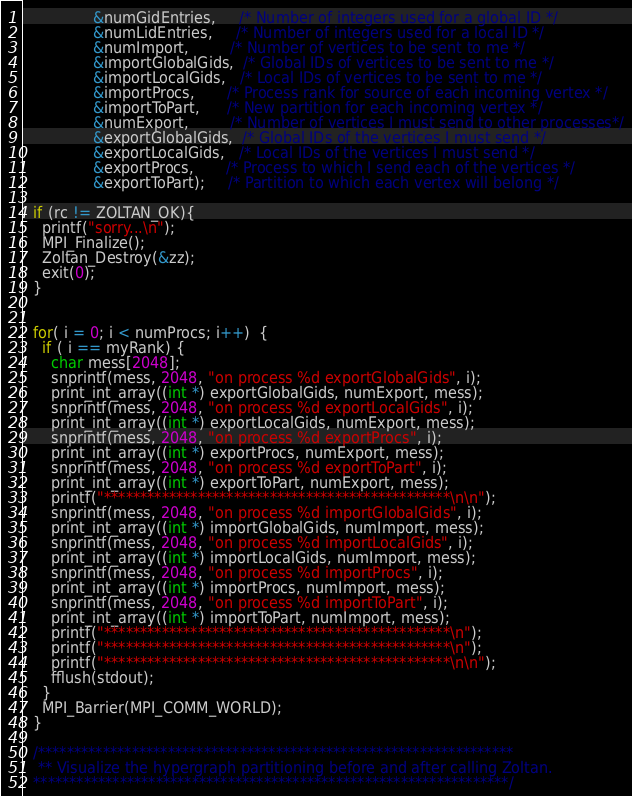Convert code to text. <code><loc_0><loc_0><loc_500><loc_500><_C_>			   &numGidEntries,     /* Number of integers used for a global ID */
			   &numLidEntries,     /* Number of integers used for a local ID */
			   &numImport,         /* Number of vertices to be sent to me */
			   &importGlobalGids,  /* Global IDs of vertices to be sent to me */
			   &importLocalGids,   /* Local IDs of vertices to be sent to me */
			   &importProcs,       /* Process rank for source of each incoming vertex */
			   &importToPart,      /* New partition for each incoming vertex */
			   &numExport,         /* Number of vertices I must send to other processes*/
			   &exportGlobalGids,  /* Global IDs of the vertices I must send */
			   &exportLocalGids,   /* Local IDs of the vertices I must send */
			   &exportProcs,       /* Process to which I send each of the vertices */
			   &exportToPart);     /* Partition to which each vertex will belong */
  
  if (rc != ZOLTAN_OK){
    printf("sorry...\n");
    MPI_Finalize();
    Zoltan_Destroy(&zz);
    exit(0);
  }


  for( i = 0; i < numProcs; i++)  {
    if ( i == myRank) {
      char mess[2048];
      snprintf(mess, 2048, "on process %d exportGlobalGids", i);
      print_int_array((int *) exportGlobalGids, numExport, mess);
      snprintf(mess, 2048, "on process %d exportLocalGids", i);
      print_int_array((int *) exportLocalGids, numExport, mess);
      snprintf(mess, 2048, "on process %d exportProcs", i);
      print_int_array((int *) exportProcs, numExport, mess);
      snprintf(mess, 2048, "on process %d exportToPart", i);
      print_int_array((int *) exportToPart, numExport, mess);
      printf("************************************************\n\n");
      snprintf(mess, 2048, "on process %d importGlobalGids", i);
      print_int_array((int *) importGlobalGids, numImport, mess);
      snprintf(mess, 2048, "on process %d importLocalGids", i);
      print_int_array((int *) importLocalGids, numImport, mess);
      snprintf(mess, 2048, "on process %d importProcs", i);
      print_int_array((int *) importProcs, numImport, mess);
      snprintf(mess, 2048, "on process %d importToPart", i);
      print_int_array((int *) importToPart, numImport, mess);
      printf("************************************************\n");
      printf("************************************************\n");
      printf("************************************************\n\n");
      fflush(stdout);
    }
    MPI_Barrier(MPI_COMM_WORLD);
  }

  /******************************************************************
   ** Visualize the hypergraph partitioning before and after calling Zoltan.
  ******************************************************************/</code> 